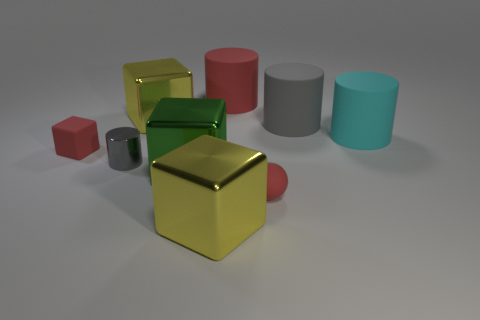Is the color of the rubber cube the same as the rubber sphere? yes 